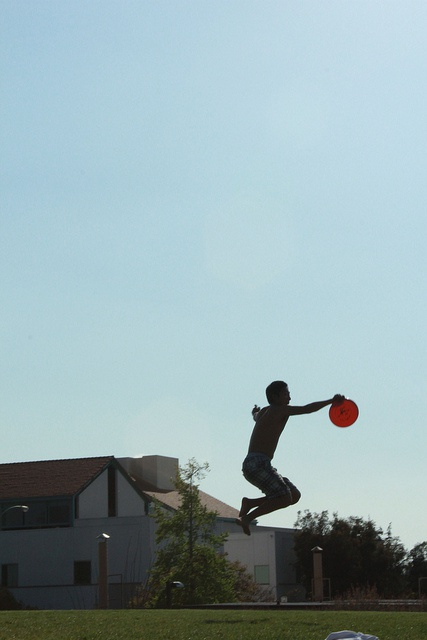Describe the objects in this image and their specific colors. I can see people in lightblue, black, gray, and darkgray tones and frisbee in lightblue, maroon, gray, and black tones in this image. 